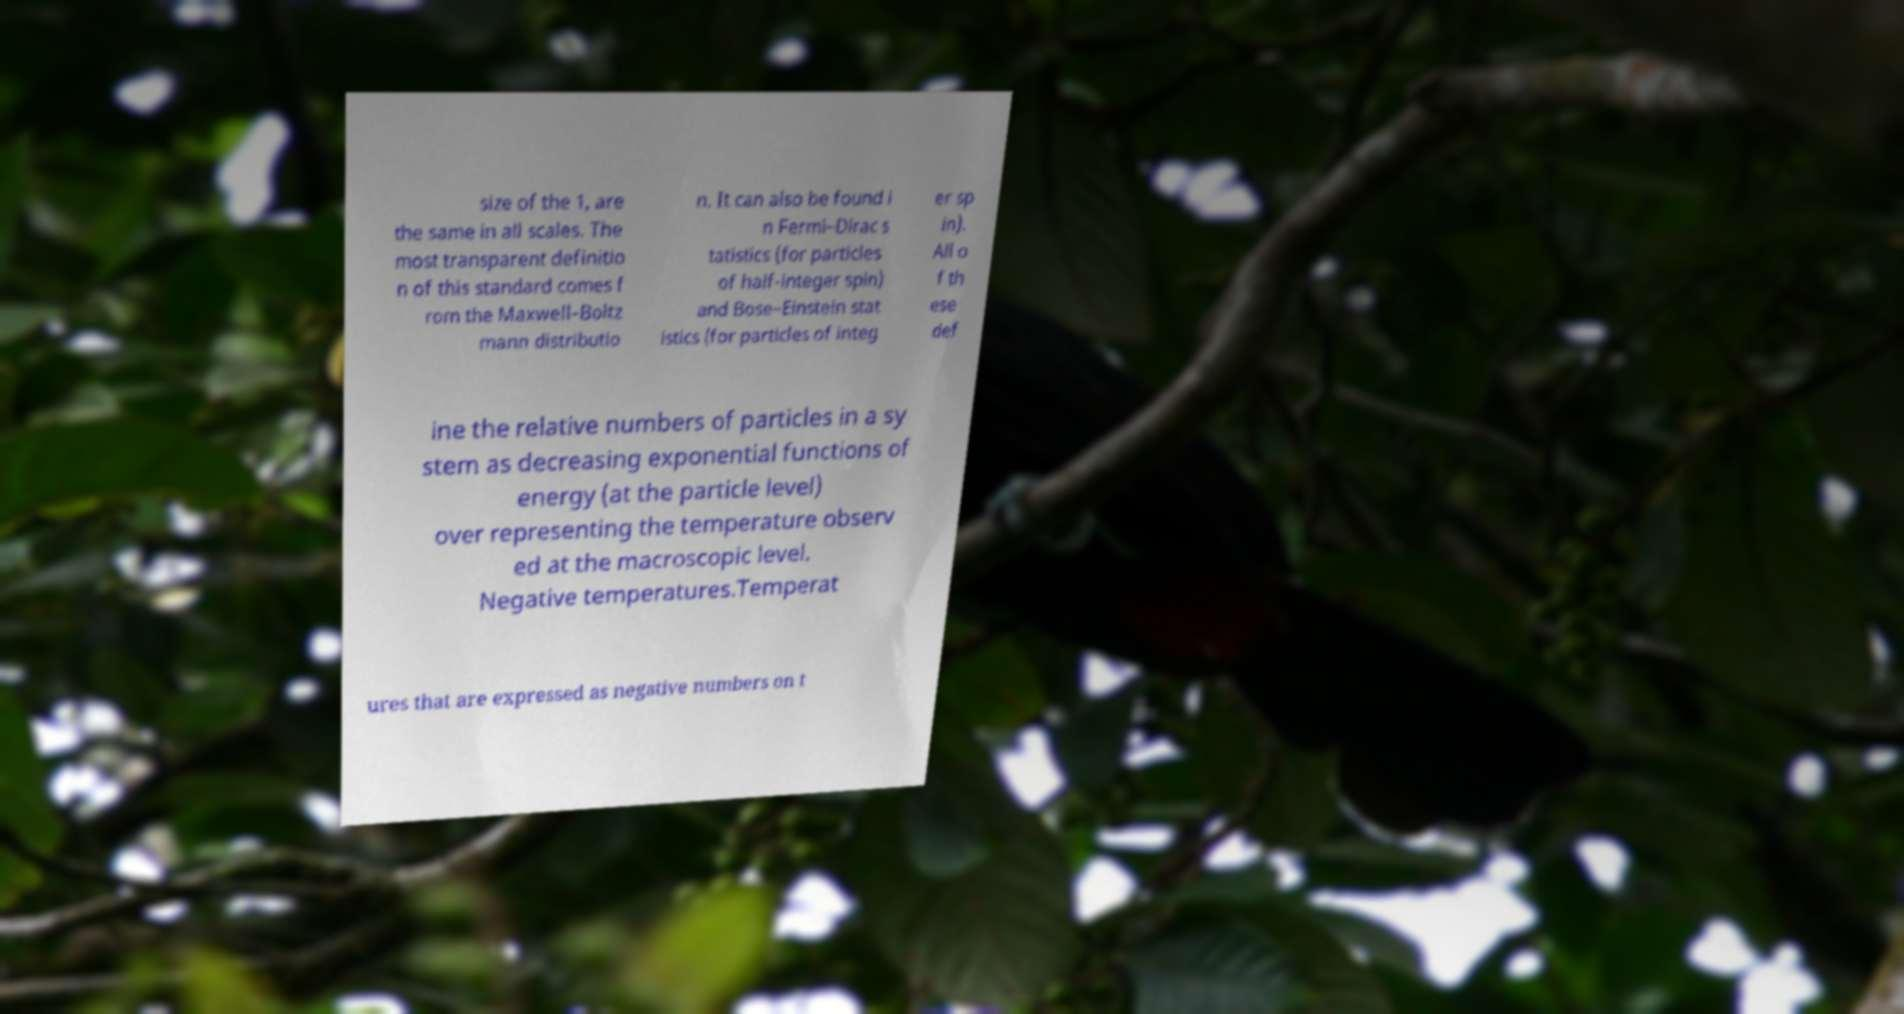Could you assist in decoding the text presented in this image and type it out clearly? size of the 1, are the same in all scales. The most transparent definitio n of this standard comes f rom the Maxwell–Boltz mann distributio n. It can also be found i n Fermi–Dirac s tatistics (for particles of half-integer spin) and Bose–Einstein stat istics (for particles of integ er sp in). All o f th ese def ine the relative numbers of particles in a sy stem as decreasing exponential functions of energy (at the particle level) over representing the temperature observ ed at the macroscopic level. Negative temperatures.Temperat ures that are expressed as negative numbers on t 